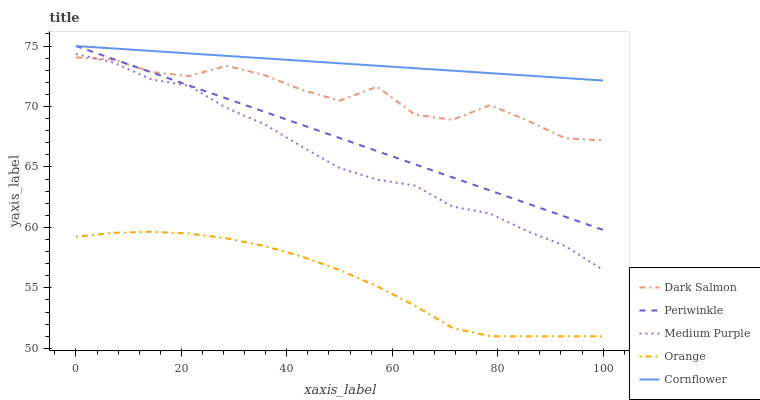Does Orange have the minimum area under the curve?
Answer yes or no. Yes. Does Cornflower have the maximum area under the curve?
Answer yes or no. Yes. Does Periwinkle have the minimum area under the curve?
Answer yes or no. No. Does Periwinkle have the maximum area under the curve?
Answer yes or no. No. Is Periwinkle the smoothest?
Answer yes or no. Yes. Is Dark Salmon the roughest?
Answer yes or no. Yes. Is Orange the smoothest?
Answer yes or no. No. Is Orange the roughest?
Answer yes or no. No. Does Orange have the lowest value?
Answer yes or no. Yes. Does Periwinkle have the lowest value?
Answer yes or no. No. Does Cornflower have the highest value?
Answer yes or no. Yes. Does Orange have the highest value?
Answer yes or no. No. Is Medium Purple less than Cornflower?
Answer yes or no. Yes. Is Periwinkle greater than Orange?
Answer yes or no. Yes. Does Dark Salmon intersect Medium Purple?
Answer yes or no. Yes. Is Dark Salmon less than Medium Purple?
Answer yes or no. No. Is Dark Salmon greater than Medium Purple?
Answer yes or no. No. Does Medium Purple intersect Cornflower?
Answer yes or no. No. 